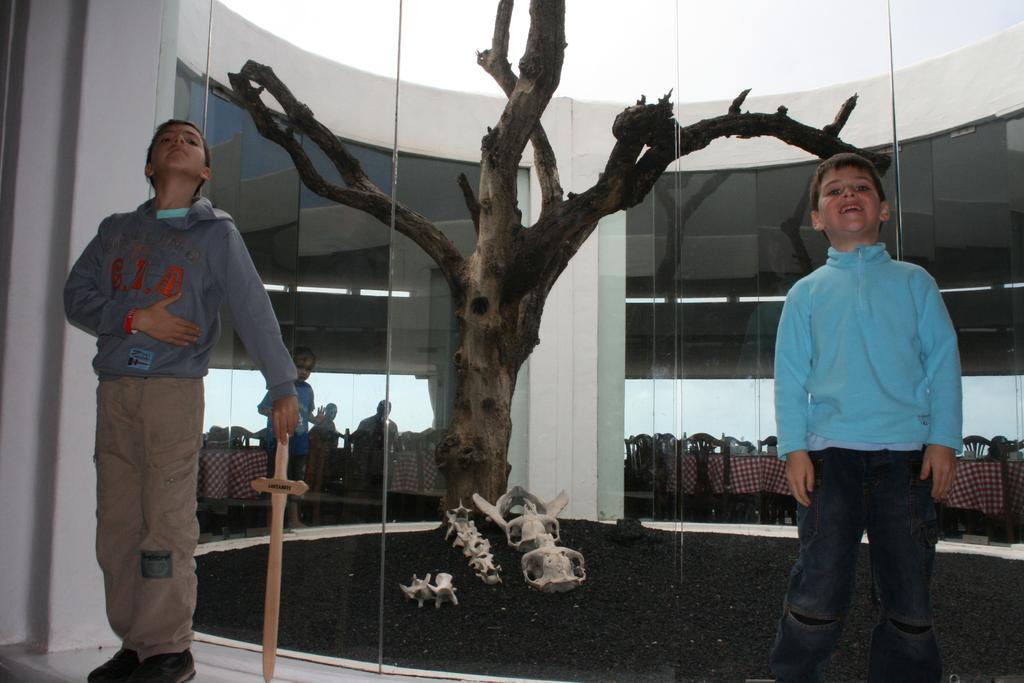Can you describe this image briefly? In the image there are two boys in hoodies standing in front of glass wall with a tree behind it and over the background there are tables and chairs with few persons standing on the left side. 